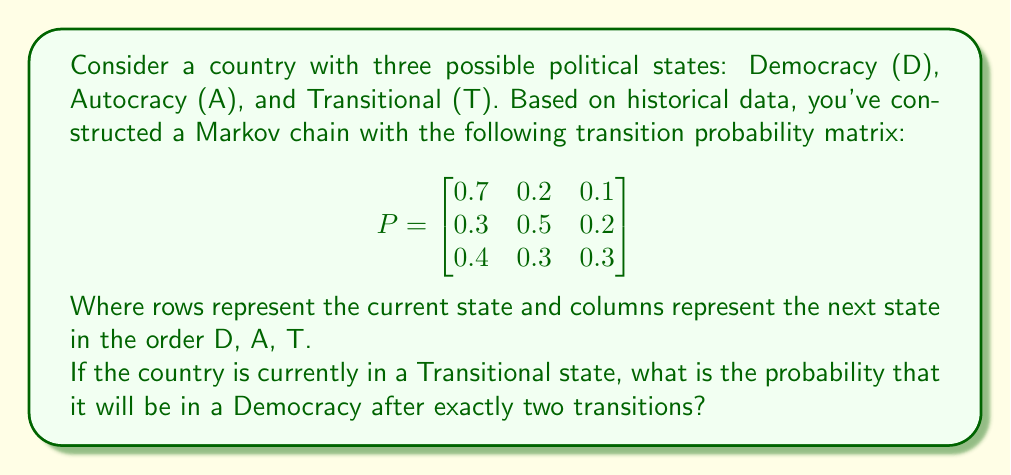Can you solve this math problem? To solve this problem, we need to use the properties of Markov chains and matrix multiplication. Let's break it down step-by-step:

1) The initial state vector for a country in a Transitional state is:
   $$v_0 = \begin{bmatrix} 0 & 0 & 1 \end{bmatrix}$$

2) To find the probability distribution after two transitions, we need to multiply the initial state vector by the transition matrix twice:
   $$v_2 = v_0 \cdot P^2$$

3) Let's calculate $P^2$:
   $$P^2 = P \cdot P = \begin{bmatrix}
   0.7 & 0.2 & 0.1 \\
   0.3 & 0.5 & 0.2 \\
   0.4 & 0.3 & 0.3
   \end{bmatrix} \cdot \begin{bmatrix}
   0.7 & 0.2 & 0.1 \\
   0.3 & 0.5 & 0.2 \\
   0.4 & 0.3 & 0.3
   \end{bmatrix}$$

4) Performing the matrix multiplication:
   $$P^2 = \begin{bmatrix}
   0.58 & 0.27 & 0.15 \\
   0.46 & 0.37 & 0.17 \\
   0.49 & 0.31 & 0.20
   \end{bmatrix}$$

5) Now, we multiply the initial state vector by $P^2$:
   $$v_2 = \begin{bmatrix} 0 & 0 & 1 \end{bmatrix} \cdot \begin{bmatrix}
   0.58 & 0.27 & 0.15 \\
   0.46 & 0.37 & 0.17 \\
   0.49 & 0.31 & 0.20
   \end{bmatrix}$$

6) This gives us:
   $$v_2 = \begin{bmatrix} 0.49 & 0.31 & 0.20 \end{bmatrix}$$

7) The probability of being in a Democracy (the first state) after two transitions is the first element of this vector: 0.49 or 49%.
Answer: The probability that the country will be in a Democracy after exactly two transitions, starting from a Transitional state, is 0.49 or 49%. 